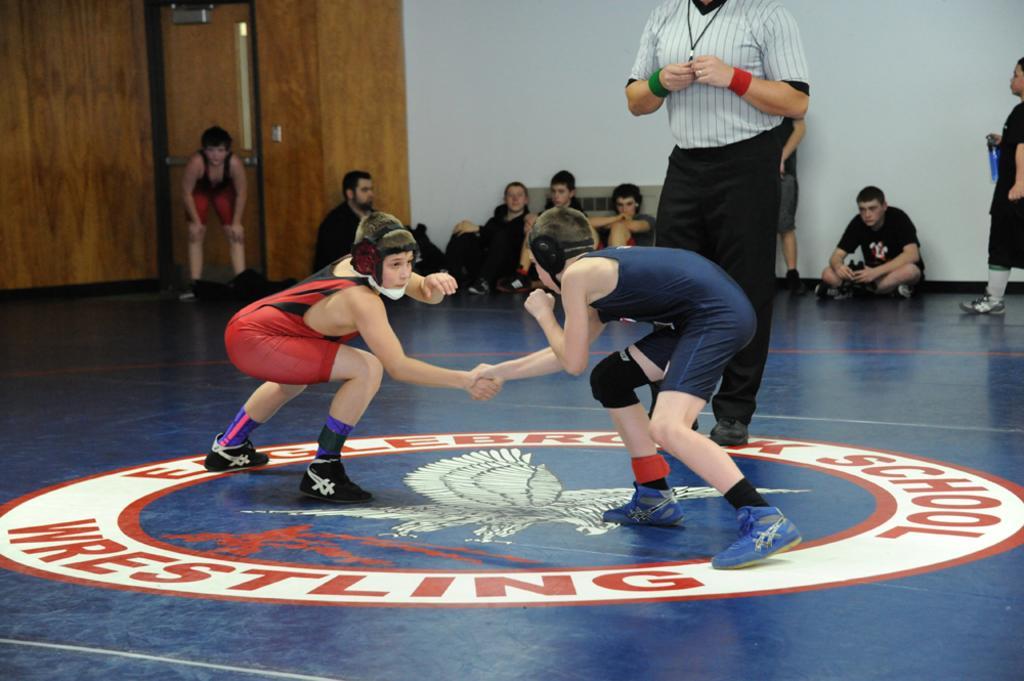In one or two sentences, can you explain what this image depicts? This image consists of a many persons. In the front, we can see two persons wrestling. Beside them there is a man standing. At the bottom, there is a floor. In the background, we can see a wall along with a door. 